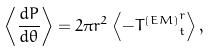<formula> <loc_0><loc_0><loc_500><loc_500>\left \langle \frac { d P } { d \theta } \right \rangle = 2 \pi r ^ { 2 } \left \langle - { T ^ { ( E M ) } } ^ { r } _ { t } \right \rangle ,</formula> 